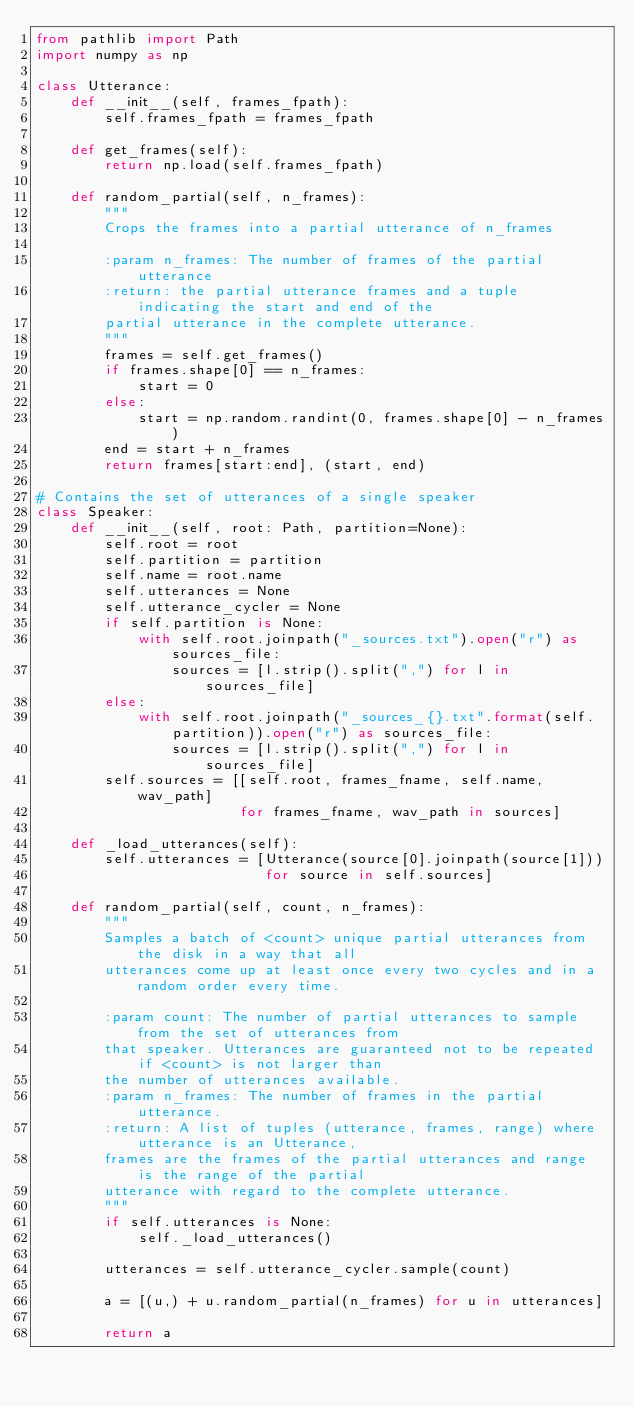Convert code to text. <code><loc_0><loc_0><loc_500><loc_500><_Python_>from pathlib import Path
import numpy as np

class Utterance:
    def __init__(self, frames_fpath):
        self.frames_fpath = frames_fpath

    def get_frames(self):
        return np.load(self.frames_fpath)

    def random_partial(self, n_frames):
        """
        Crops the frames into a partial utterance of n_frames
        
        :param n_frames: The number of frames of the partial utterance
        :return: the partial utterance frames and a tuple indicating the start and end of the 
        partial utterance in the complete utterance.
        """
        frames = self.get_frames()
        if frames.shape[0] == n_frames:
            start = 0
        else:
            start = np.random.randint(0, frames.shape[0] - n_frames)
        end = start + n_frames
        return frames[start:end], (start, end)

# Contains the set of utterances of a single speaker
class Speaker:
    def __init__(self, root: Path, partition=None):
        self.root = root
        self.partition = partition
        self.name = root.name
        self.utterances = None
        self.utterance_cycler = None
        if self.partition is None:
            with self.root.joinpath("_sources.txt").open("r") as sources_file:
                sources = [l.strip().split(",") for l in sources_file]
        else:
            with self.root.joinpath("_sources_{}.txt".format(self.partition)).open("r") as sources_file:
                sources = [l.strip().split(",") for l in sources_file]
        self.sources = [[self.root, frames_fname, self.name, wav_path]
                        for frames_fname, wav_path in sources]

    def _load_utterances(self):
        self.utterances = [Utterance(source[0].joinpath(source[1]))
                           for source in self.sources]

    def random_partial(self, count, n_frames):
        """
        Samples a batch of <count> unique partial utterances from the disk in a way that all
        utterances come up at least once every two cycles and in a random order every time.

        :param count: The number of partial utterances to sample from the set of utterances from
        that speaker. Utterances are guaranteed not to be repeated if <count> is not larger than
        the number of utterances available.
        :param n_frames: The number of frames in the partial utterance.
        :return: A list of tuples (utterance, frames, range) where utterance is an Utterance,
        frames are the frames of the partial utterances and range is the range of the partial
        utterance with regard to the complete utterance.
        """
        if self.utterances is None:
            self._load_utterances()

        utterances = self.utterance_cycler.sample(count)

        a = [(u,) + u.random_partial(n_frames) for u in utterances]

        return a
</code> 